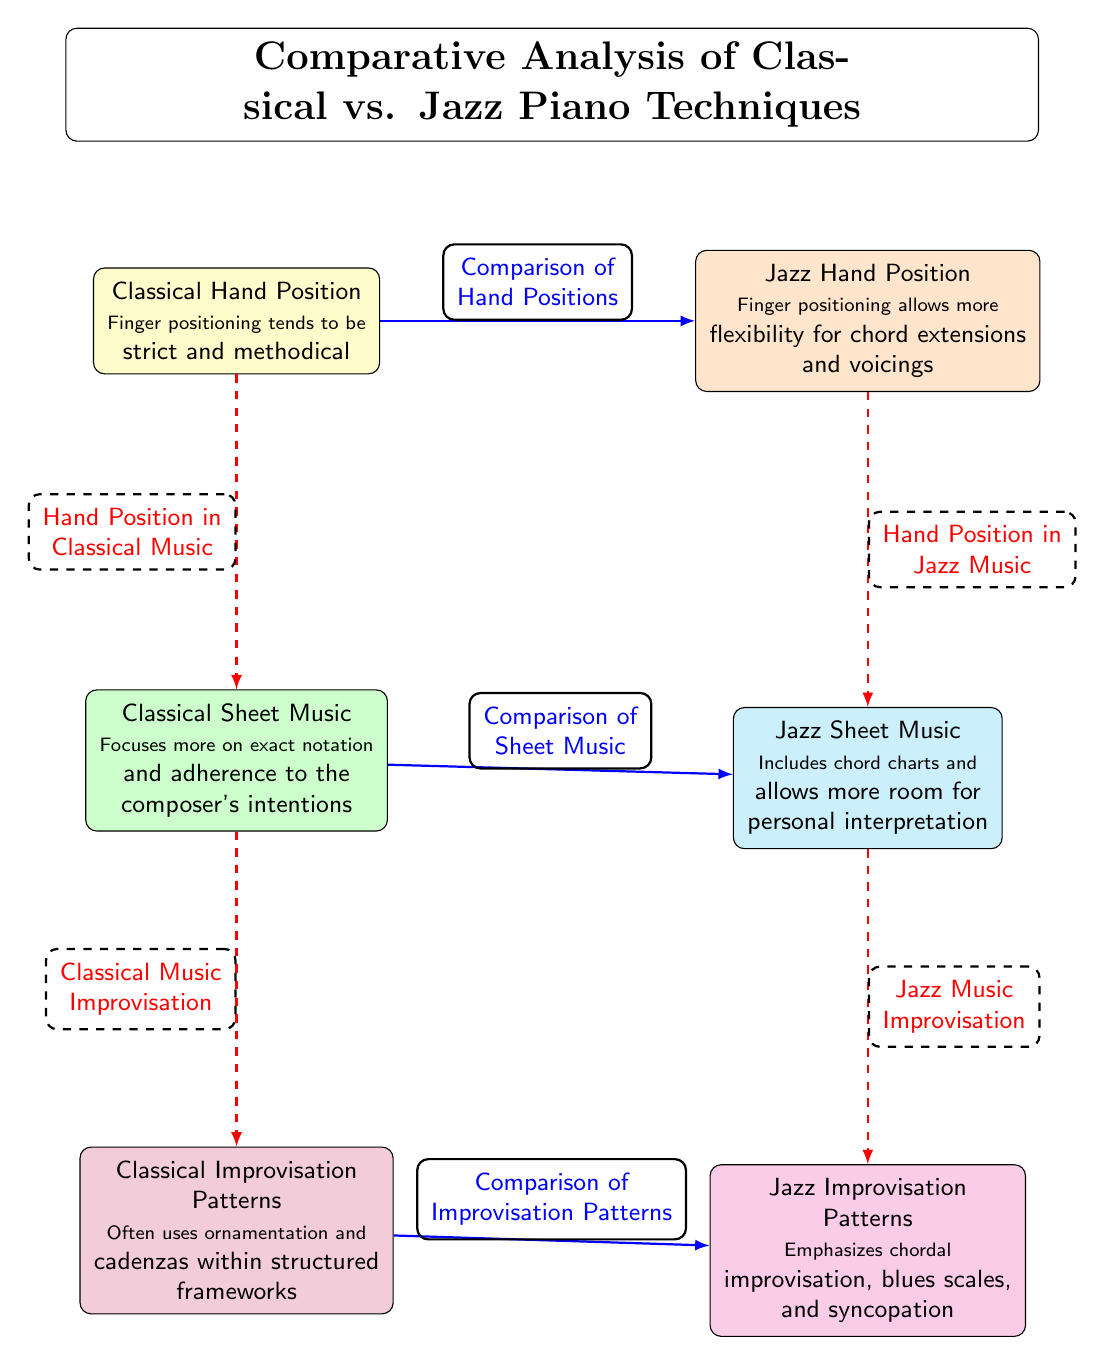What are the two types of hand positions compared in the diagram? The diagram labels two types of hand positions: "Classical Hand Position" and "Jazz Hand Position," providing a clear comparison between them.
Answer: Classical Hand Position, Jazz Hand Position Which sheet music type emphasizes personal interpretation? In the diagram, "Jazz Sheet Music" is specifically noted to allow more room for personal interpretation compared to "Classical Sheet Music."
Answer: Jazz Sheet Music What is the focus of Classical Sheet Music? The description under "Classical Sheet Music" states that it focuses more on exact notation, indicating a detailed adherence to the composer’s intentions.
Answer: Exact notation How many nodes represent improvisation patterns in the diagram? The diagram includes two nodes that specifically represent improvisation patterns: "Classical Improvisation Patterns" and "Jazz Improvisation Patterns."
Answer: 2 What relationship is indicated between Classical Hand Position and Classical Music Improvisation? The diagram shows a direct relationship between "Classical Hand Position" and "Classical Music Improvisation," indicating that hand position influences improvisation in classical music.
Answer: Hand Position in Classical Music Which hand position allows more flexibility for chord extensions? According to the diagram, the "Jazz Hand Position" allows for more flexibility regarding chord extensions and voicings compared to its classical counterpart.
Answer: Jazz Hand Position Explain how improvisation in jazz differs from classical improvisation based on the diagram. The diagram indicates that "Jazz Improvisation Patterns" emphasize chordal improvisation, blues scales, and syncopation, while "Classical Improvisation Patterns" utilize ornamentation and cadenzas within structured frameworks, highlighting a fundamental difference in approach to improvisation.
Answer: Emphasizes chordal improvisation What is the title of the diagram? The title of the diagram is explicitly stated at the top: "Comparative Analysis of Classical vs. Jazz Piano Techniques."
Answer: Comparative Analysis of Classical vs. Jazz Piano Techniques 